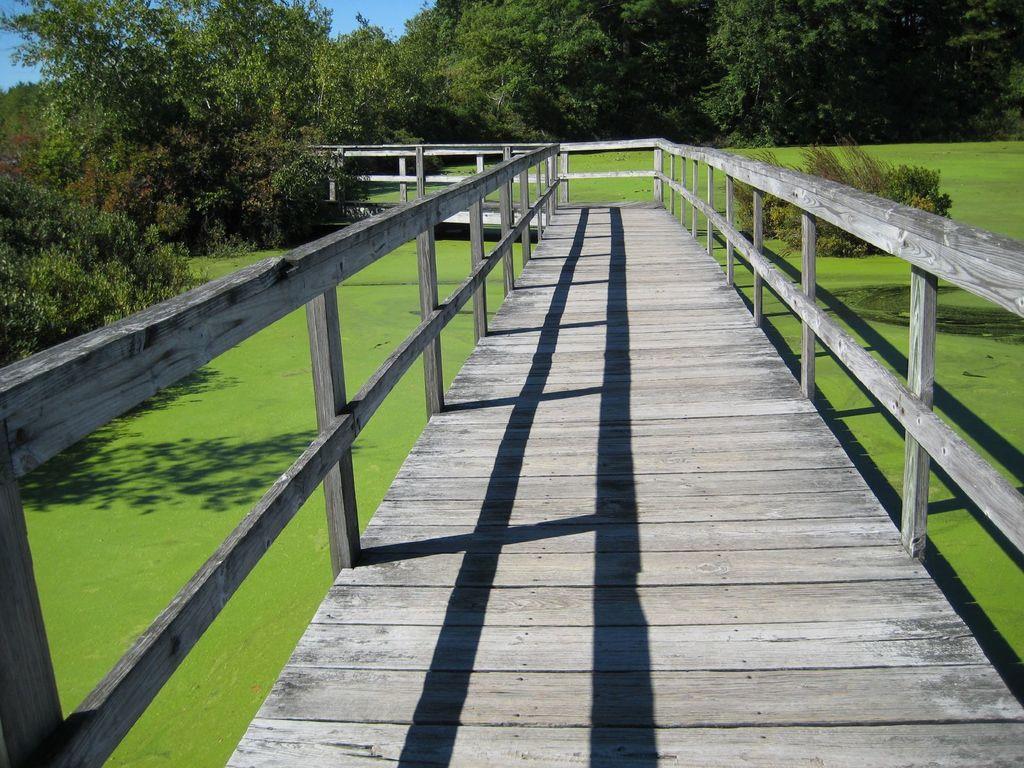Could you give a brief overview of what you see in this image? In this picture there is a wooden bridge with railing on both the sides. Behind there are some trees and in the bottom side there is a green lawn. 